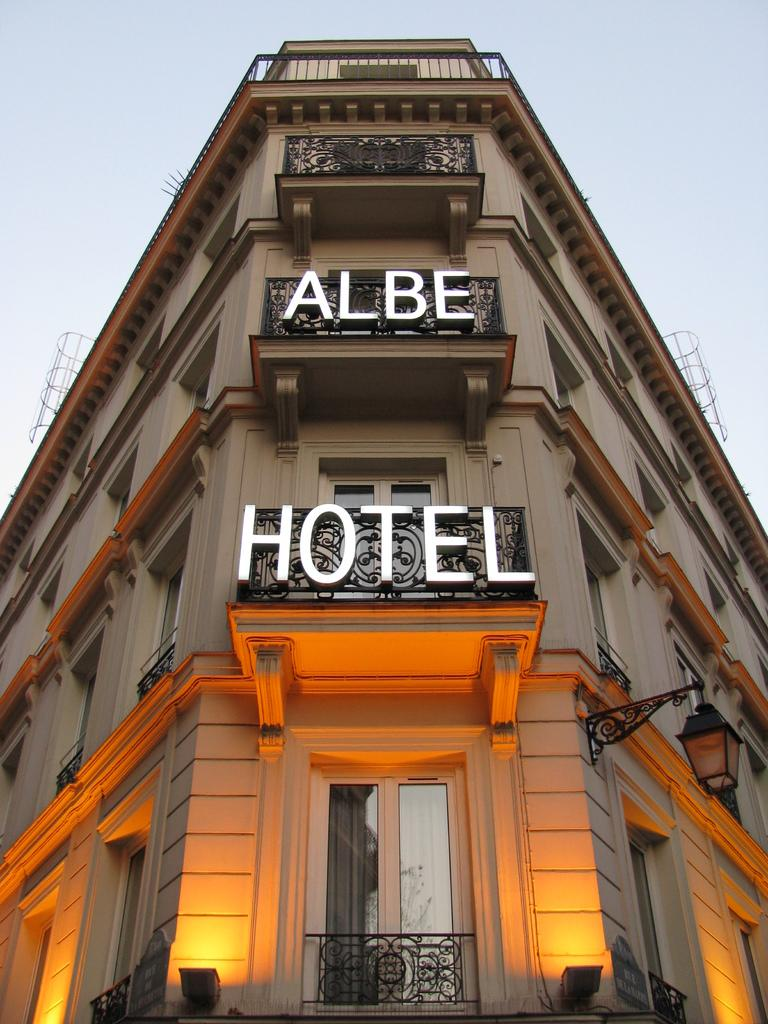What type of structure is present in the image? There is a building in the image. What features can be seen on the building? The building has a lamp, lights, windows, and a fence. What is written on the building? The text "Albe hotel" is written on the building. Can you tell me about the discussion taking place in the building? There is no information about a discussion taking place inside the building in the image. What type of slip is visible on the floor of the building? There is no slip visible on the floor of the building in the image. 